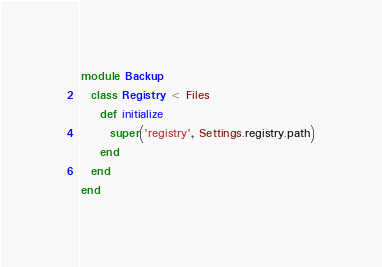<code> <loc_0><loc_0><loc_500><loc_500><_Ruby_>module Backup
  class Registry < Files
    def initialize
      super('registry', Settings.registry.path)
    end
  end
end
</code> 